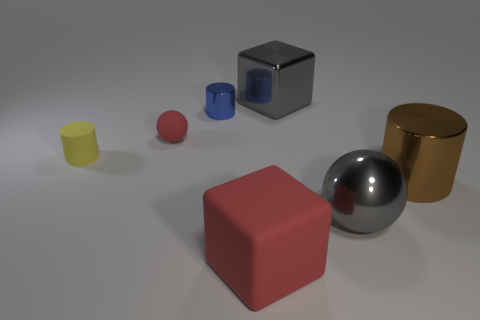How many small objects are made of the same material as the gray block?
Provide a short and direct response. 1. Does the yellow object have the same shape as the tiny red thing?
Offer a terse response. No. What is the size of the cylinder that is behind the red object behind the red object that is on the right side of the tiny metal thing?
Offer a very short reply. Small. Are there any large shiny objects in front of the metallic cylinder that is in front of the blue metal cylinder?
Offer a very short reply. Yes. What number of blocks are in front of the ball on the right side of the small thing that is behind the red matte ball?
Keep it short and to the point. 1. What is the color of the large shiny object that is to the left of the large brown cylinder and in front of the big gray block?
Offer a very short reply. Gray. What number of tiny matte things are the same color as the rubber cylinder?
Provide a short and direct response. 0. What number of cylinders are red rubber objects or big rubber objects?
Offer a very short reply. 0. The shiny cube that is the same size as the brown shiny thing is what color?
Keep it short and to the point. Gray. Are there any tiny metal cylinders behind the red matte object that is in front of the small cylinder that is in front of the blue metallic cylinder?
Provide a succinct answer. Yes. 